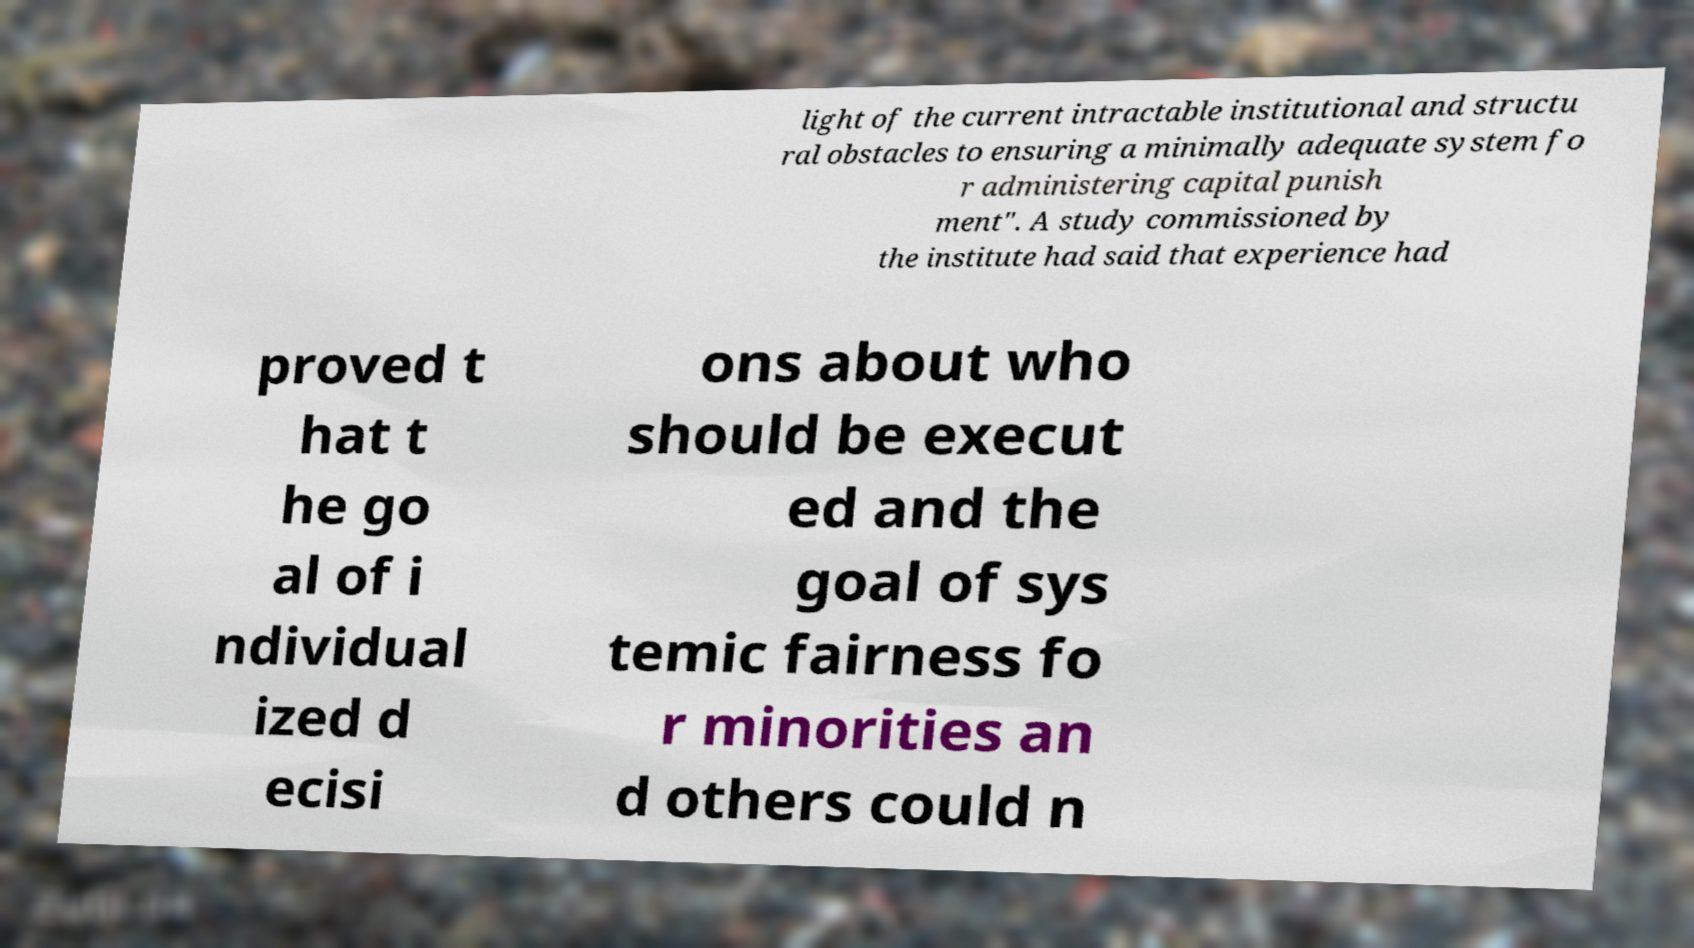I need the written content from this picture converted into text. Can you do that? light of the current intractable institutional and structu ral obstacles to ensuring a minimally adequate system fo r administering capital punish ment". A study commissioned by the institute had said that experience had proved t hat t he go al of i ndividual ized d ecisi ons about who should be execut ed and the goal of sys temic fairness fo r minorities an d others could n 